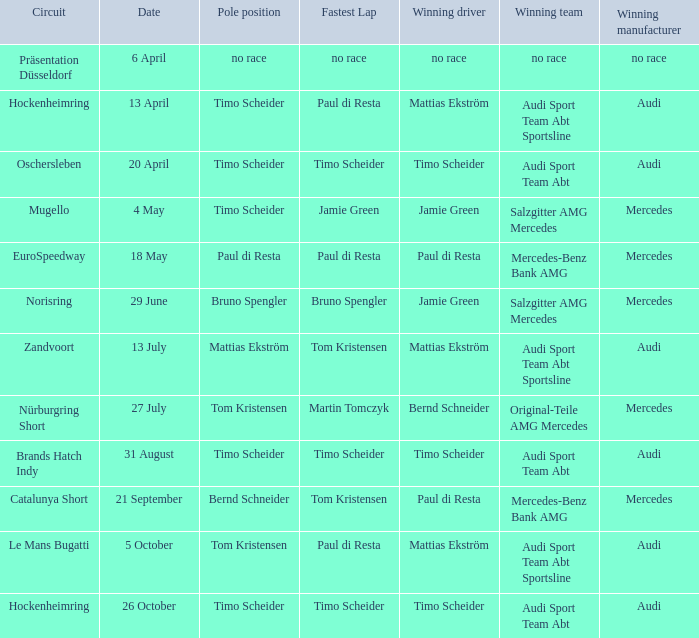What is the fastest lap in the Le Mans Bugatti circuit? Paul di Resta. 